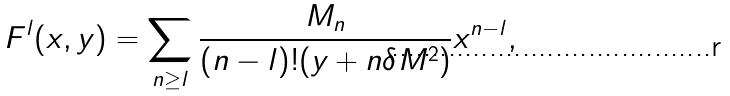Convert formula to latex. <formula><loc_0><loc_0><loc_500><loc_500>F ^ { l } ( x , y ) = \sum _ { n \geq l } \frac { M _ { n } } { ( n - l ) ! ( y + n \delta M ^ { 2 } ) } x ^ { n - l } ,</formula> 